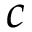<formula> <loc_0><loc_0><loc_500><loc_500>c</formula> 